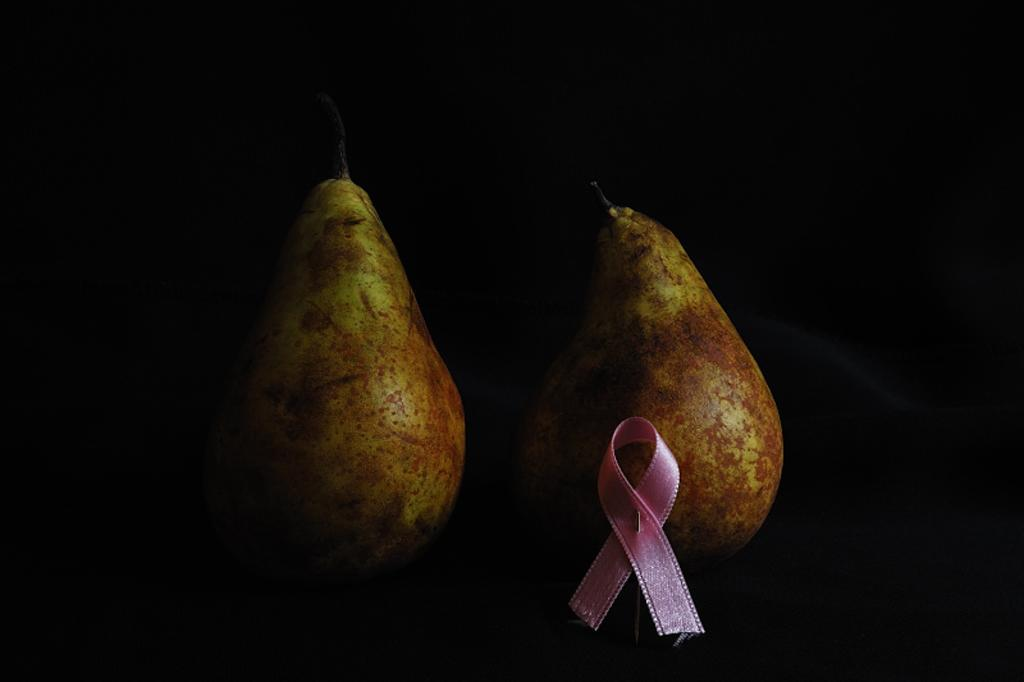What type of fruit is in the center of the image? There are two green apples in the center of the image. What other object can be seen in the image besides the apples? There is a pink color ribbon in the image. What type of behavior is exhibited by the bed in the image? There is no bed present in the image, so it is not possible to determine any behavior. 